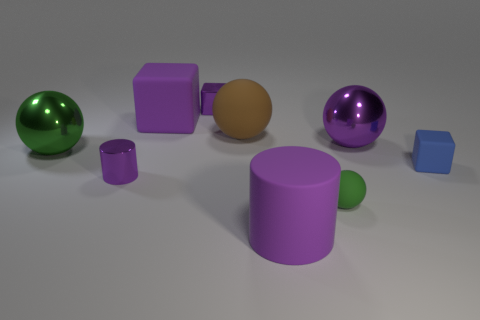Subtract all tiny green spheres. How many spheres are left? 3 Add 1 big blocks. How many objects exist? 10 Subtract all purple blocks. How many blocks are left? 1 Subtract 2 balls. How many balls are left? 2 Add 6 big shiny things. How many big shiny things are left? 8 Add 7 small green matte things. How many small green matte things exist? 8 Subtract 0 red cylinders. How many objects are left? 9 Subtract all cylinders. How many objects are left? 7 Subtract all gray balls. Subtract all green cylinders. How many balls are left? 4 Subtract all green blocks. How many purple balls are left? 1 